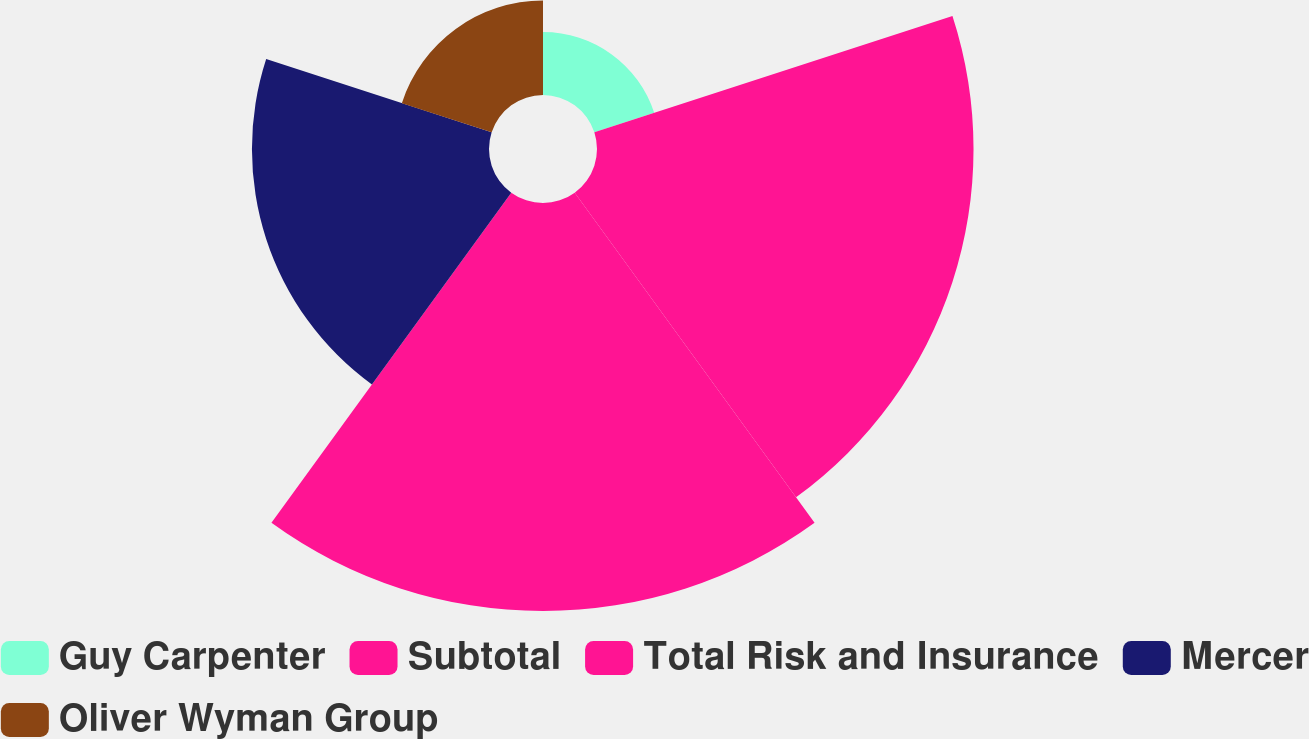<chart> <loc_0><loc_0><loc_500><loc_500><pie_chart><fcel>Guy Carpenter<fcel>Subtotal<fcel>Total Risk and Insurance<fcel>Mercer<fcel>Oliver Wyman Group<nl><fcel>5.34%<fcel>31.94%<fcel>34.61%<fcel>20.11%<fcel>8.01%<nl></chart> 